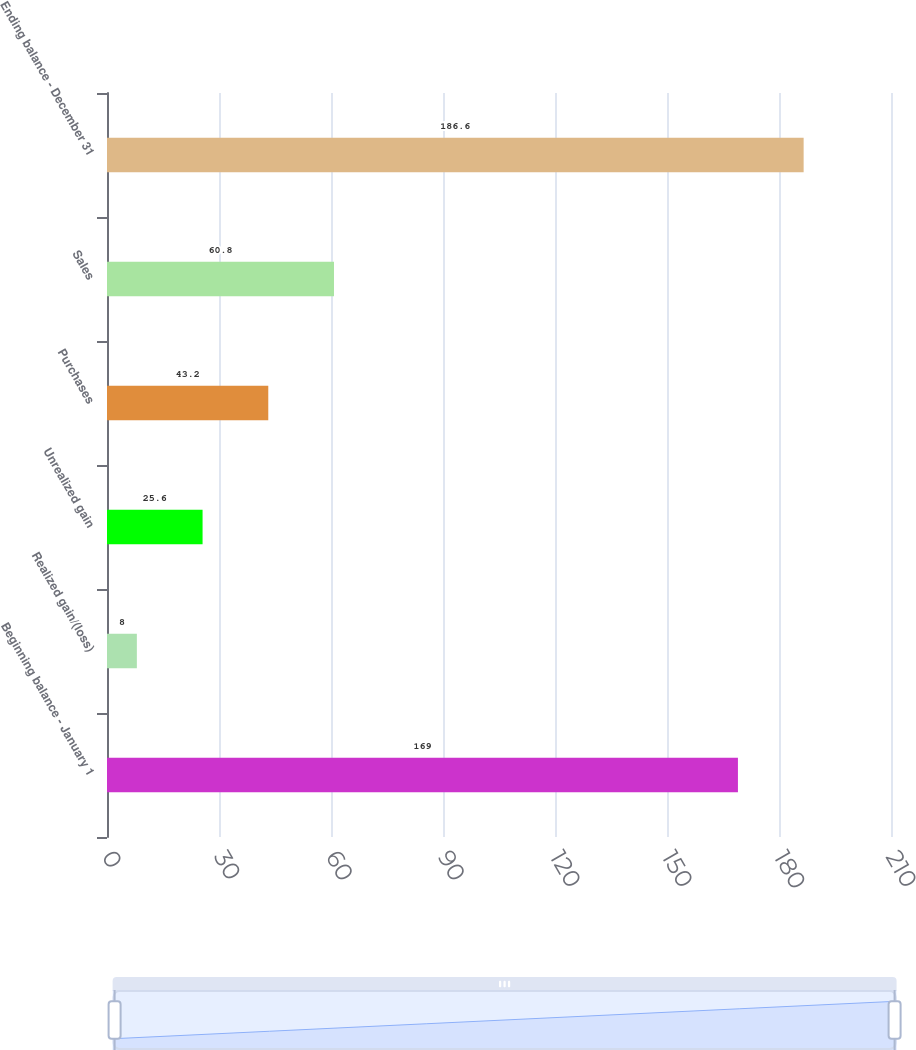Convert chart. <chart><loc_0><loc_0><loc_500><loc_500><bar_chart><fcel>Beginning balance - January 1<fcel>Realized gain/(loss)<fcel>Unrealized gain<fcel>Purchases<fcel>Sales<fcel>Ending balance - December 31<nl><fcel>169<fcel>8<fcel>25.6<fcel>43.2<fcel>60.8<fcel>186.6<nl></chart> 